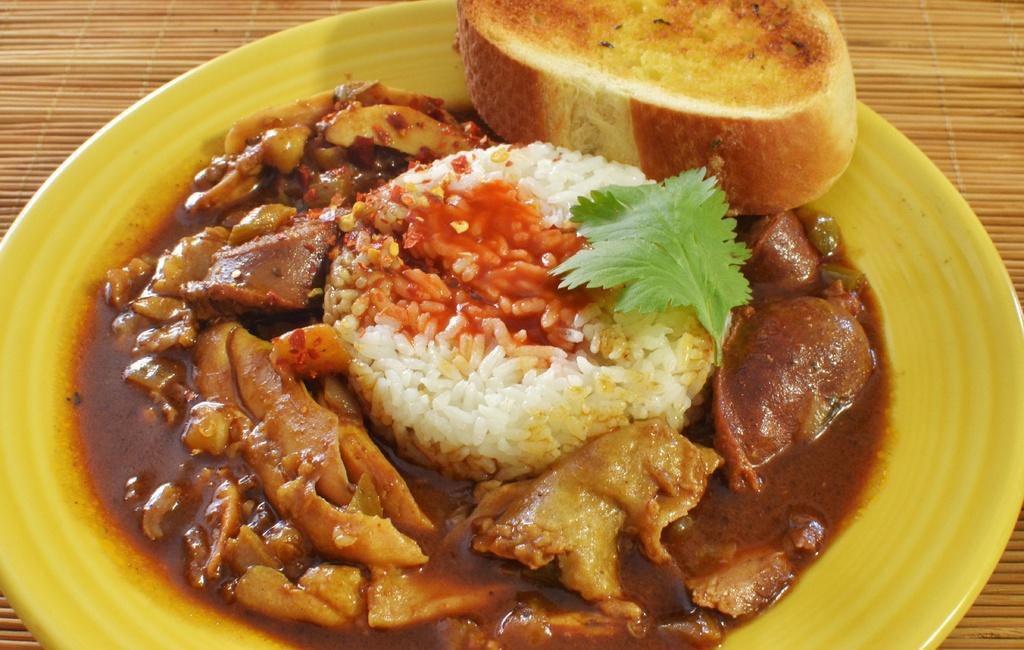Could you give a brief overview of what you see in this image? In this image there are some food items served on the plate and the plate is on the table. 